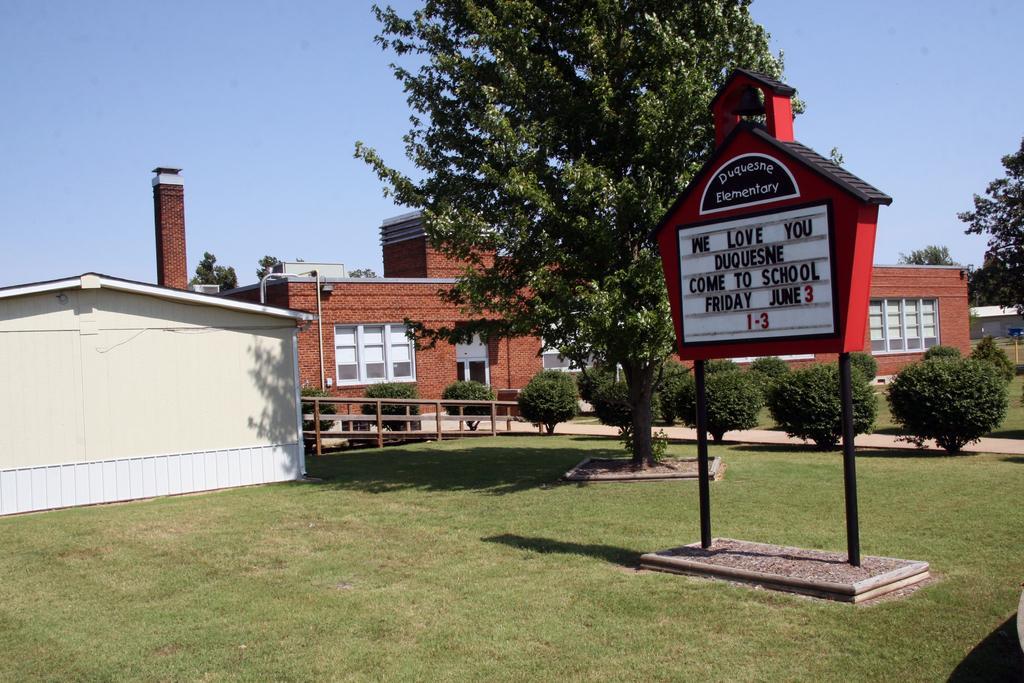In one or two sentences, can you explain what this image depicts? In this picture we can see a name board, trees, grass, path, houses with windows and in the background we can see the sky. 